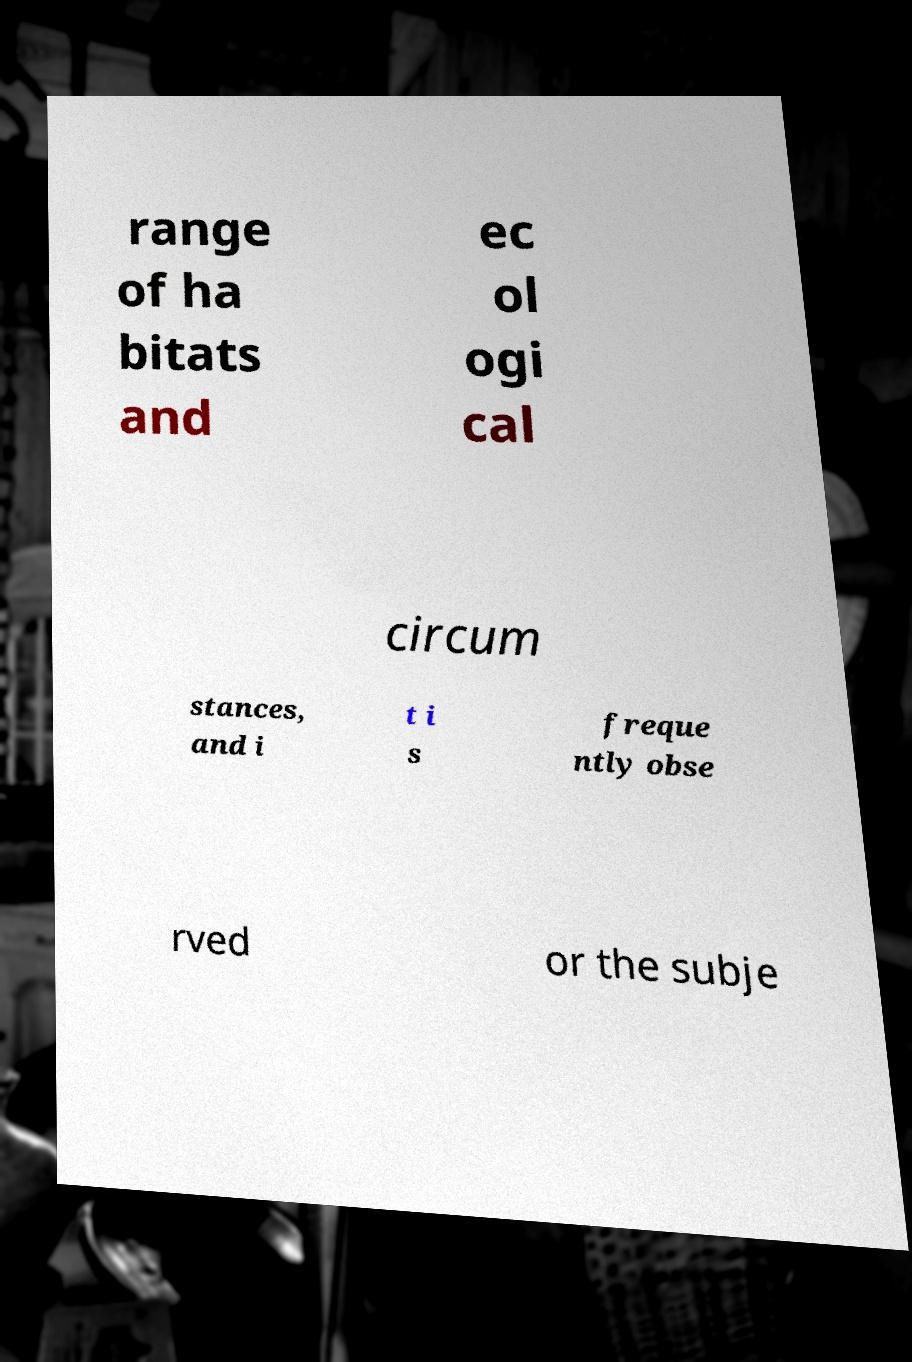Could you extract and type out the text from this image? range of ha bitats and ec ol ogi cal circum stances, and i t i s freque ntly obse rved or the subje 